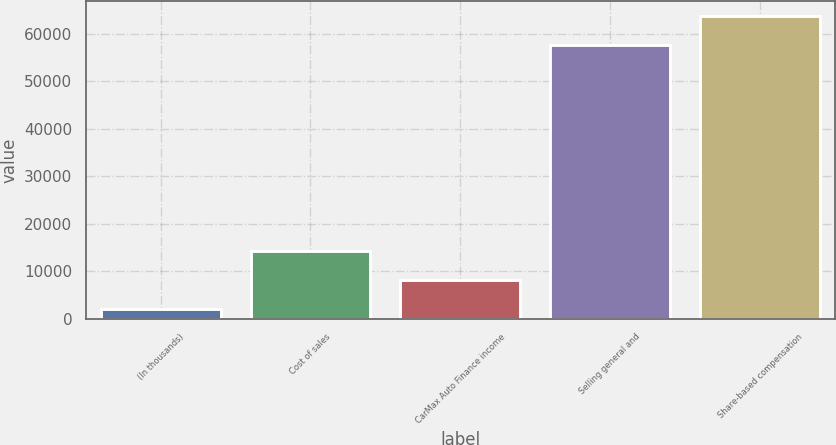Convert chart. <chart><loc_0><loc_0><loc_500><loc_500><bar_chart><fcel>(In thousands)<fcel>Cost of sales<fcel>CarMax Auto Finance income<fcel>Selling general and<fcel>Share-based compensation<nl><fcel>2013<fcel>14245.2<fcel>8129.1<fcel>57643<fcel>63759.1<nl></chart> 